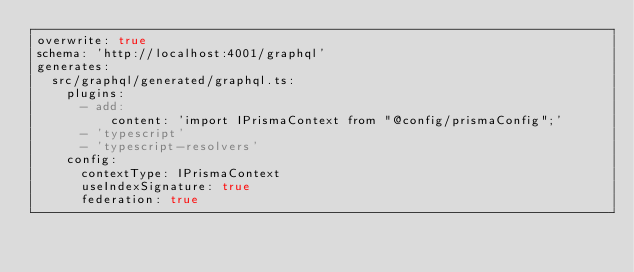<code> <loc_0><loc_0><loc_500><loc_500><_YAML_>overwrite: true
schema: 'http://localhost:4001/graphql'
generates:
  src/graphql/generated/graphql.ts:
    plugins:
      - add:
          content: 'import IPrismaContext from "@config/prismaConfig";'
      - 'typescript'
      - 'typescript-resolvers'
    config:
      contextType: IPrismaContext
      useIndexSignature: true
      federation: true
</code> 